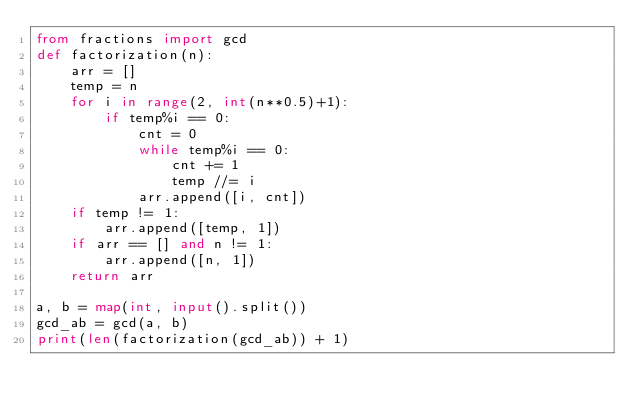Convert code to text. <code><loc_0><loc_0><loc_500><loc_500><_Python_>from fractions import gcd
def factorization(n):
    arr = []
    temp = n
    for i in range(2, int(n**0.5)+1):
        if temp%i == 0:
            cnt = 0
            while temp%i == 0:
                cnt += 1
                temp //= i
            arr.append([i, cnt])
    if temp != 1:
        arr.append([temp, 1])
    if arr == [] and n != 1:
        arr.append([n, 1])
    return arr

a, b = map(int, input().split())
gcd_ab = gcd(a, b)
print(len(factorization(gcd_ab)) + 1)</code> 